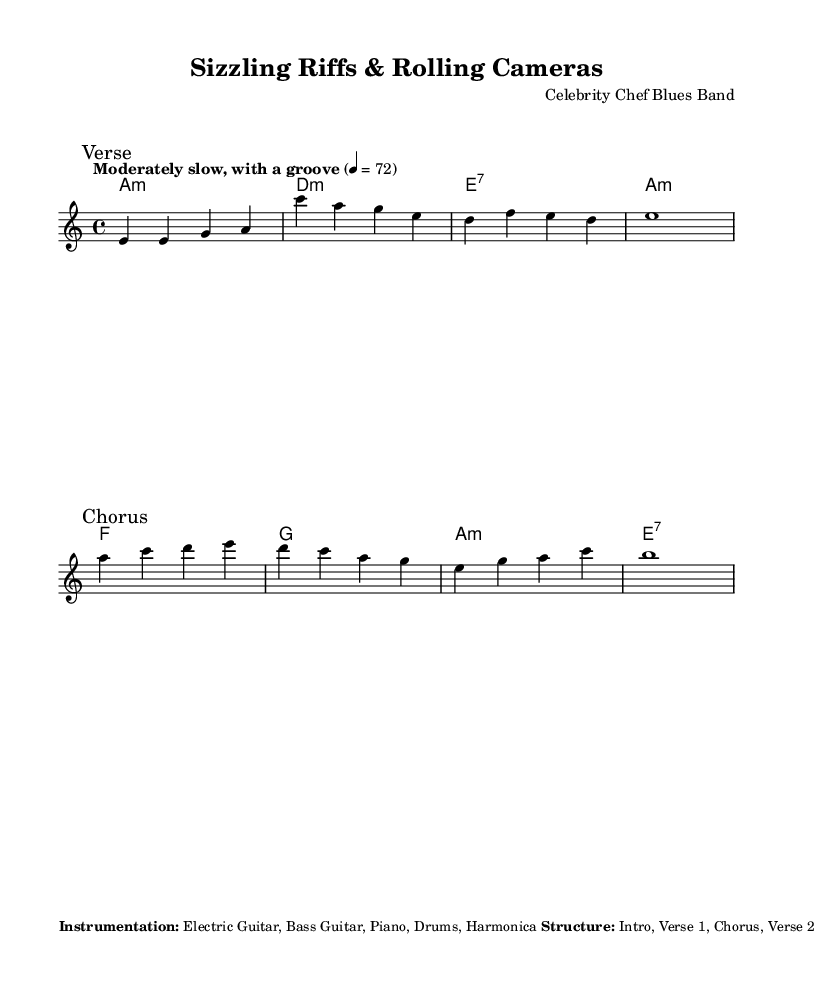What is the key signature of this music? The key signature is represented by the "a minor" indication, which consists of no sharps or flats. This can be found in the global context of the lilypond code under the key signature declaration.
Answer: a minor What is the time signature of this piece? The time signature is indicated as "4/4" in the global section of the sheet music, showing that the piece is in four beats per measure, which is a common signature for blues music.
Answer: 4/4 What is the tempo marking for this composition? The tempo marking states "Moderately slow, with a groove" with a metronome marking of 72 beats per minute. This is found in the global context of the lilypond code.
Answer: Moderately slow, with a groove How many measures are there in the verse? The verse comprises a series of chords and melody lines, totaling four measures as indicated by the melody notes written out under the "Verse" mark.
Answer: 4 What unique cooking-related sound effects are instructed to be used? The special instructions mention incorporating cooking-related sound effects, specifically a "sizzling pan" in the intro and outro. This shows the blending of culinary arts with music.
Answer: Sizzling pan What instrument is indicated to emulate the sound of a kitchen timer? The harmonica is explicitly mentioned in the special instructions to emulate the sound of a kitchen timer in the outro. This detail highlights the creative use of everyday sounds in music.
Answer: Harmonica Which section follows the second chorus in the structure? The structure outlined specifies that the section following the second chorus is the "Bridge," indicating a change in musical style or theme that comes after the repeated chorus sections.
Answer: Bridge 